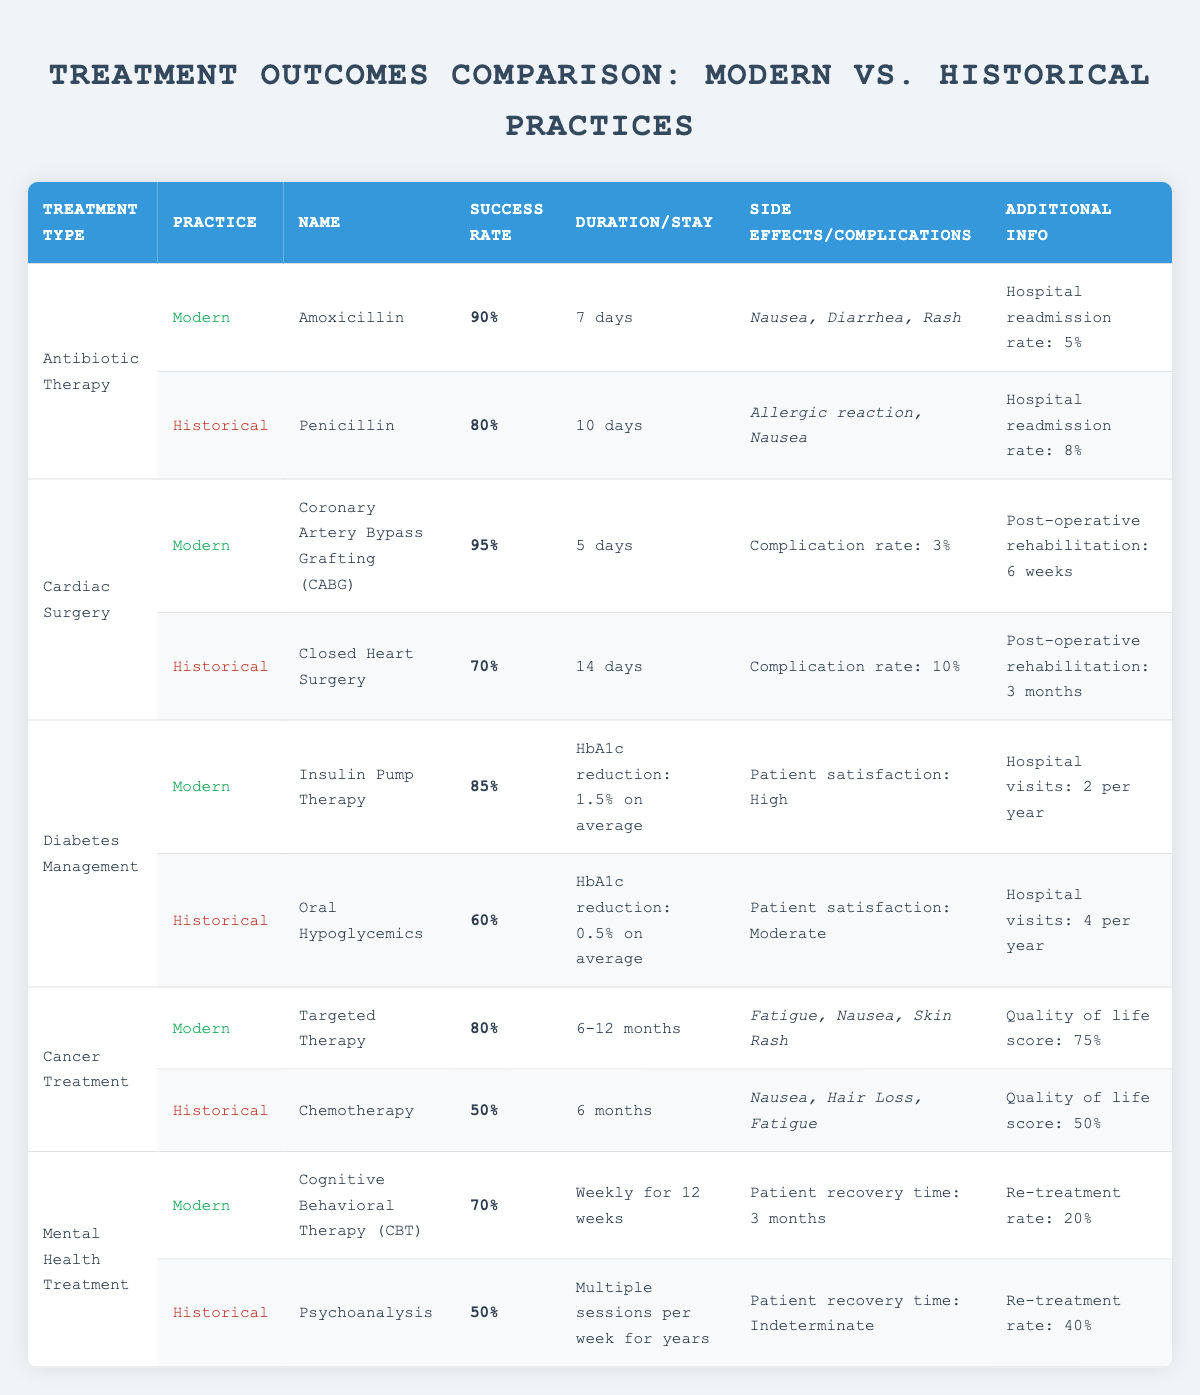What is the success rate of modern antibiotic therapy? The table shows that the success rate for modern antibiotic therapy (Amoxicillin) is 90%.
Answer: 90% How long is the average duration of modern diabetes management treatment? According to the table, the average duration for modern diabetes management (Insulin Pump Therapy) is a reduction of HbA1c by 1.5% on average, but no specific duration is listed unlike the historical methods.
Answer: Not specified What are the side effects of historical cancer treatment? The table lists the side effects of historical cancer treatment (Chemotherapy) as nausea, hair loss, and fatigue.
Answer: Nausea, Hair Loss, Fatigue What is the hospital readmission rate for modern antibiotic therapy? The modern practice of antibiotic therapy shows a hospital readmission rate of 5% according to the table.
Answer: 5% Which treatment has a higher success rate: modern cardiac surgery or historical cardiac surgery? The modern cardiac surgery (CABG) has a success rate of 95%, while historical cardiac surgery has a success rate of 70%. Thus, modern has a higher success rate.
Answer: Modern cardiac surgery What is the average length of stay for patients undergoing historical cardiac surgery? The table specifies that the average length of stay for historical cardiac surgery (Closed Heart Surgery) is 14 days.
Answer: 14 days What percentage difference in success rates exists between modern and historical diabetes management? Modern diabetes management has a success rate of 85%, and historical management has a success rate of 60%. The difference can be calculated as 85% - 60% = 25%.
Answer: 25% Which treatment shows a higher quality of life score, modern cancer treatment or historical cancer treatment? The table indicates that modern cancer treatment (Targeted Therapy) has a quality of life score of 75%, while historical treatment (Chemotherapy) has a score of 50%, hence modern treatment shows a higher score.
Answer: Modern cancer treatment How many weeks is the post-operative rehabilitation after modern cardiac surgery? The table shows that post-operative rehabilitation after modern cardiac surgery (CABG) is 6 weeks long.
Answer: 6 weeks What is the re-treatment rate for historical mental health treatment? The historical mental health treatment (Psychoanalysis) has a re-treatment rate of 40% according to the table.
Answer: 40% If patients in modern diabetes management require 2 hospital visits per year, how many visits would they require after 5 years? If patients need 2 visits per year, after 5 years they would need 2 visits/year * 5 years = 10 visits total.
Answer: 10 visits What are the key side effects reported for modern cancer treatment? The side effects for modern cancer treatment (Targeted Therapy) mentioned in the table include fatigue, nausea, and skin rash.
Answer: Fatigue, Nausea, Skin Rash Which treatment has a lower complication rate: modern or historical cardiac surgery? Modern cardiac surgery shows a complication rate of 3%, while historical shows a higher rate of 10%, hence modern has a lower complication rate.
Answer: Modern cardiac surgery Does modern mental health treatment have a better success rate than historical mental health treatment? The modern mental health treatment (CBT) shows a success rate of 70%, while historical treatment (Psychoanalysis) shows 50%, confirming that modern treatment is better.
Answer: Yes What is the duration of the average length of stay for the historical cardiac surgery practice? As per the table, the average length of stay for historical cardiac surgery (Closed Heart Surgery) is listed as 14 days.
Answer: 14 days What is the HbA1c reduction associated with modern diabetes management? The table shows that the HbA1c reduction for modern diabetes management (Insulin Pump Therapy) is an average of 1.5%.
Answer: 1.5% 